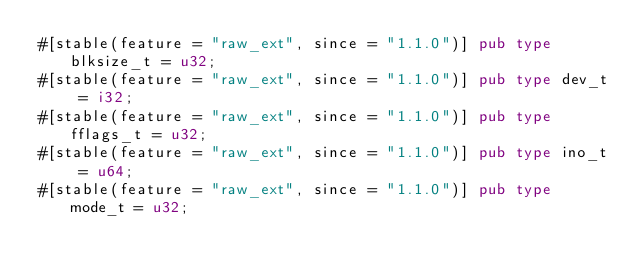Convert code to text. <code><loc_0><loc_0><loc_500><loc_500><_Rust_>#[stable(feature = "raw_ext", since = "1.1.0")] pub type blksize_t = u32;
#[stable(feature = "raw_ext", since = "1.1.0")] pub type dev_t = i32;
#[stable(feature = "raw_ext", since = "1.1.0")] pub type fflags_t = u32;
#[stable(feature = "raw_ext", since = "1.1.0")] pub type ino_t = u64;
#[stable(feature = "raw_ext", since = "1.1.0")] pub type mode_t = u32;</code> 